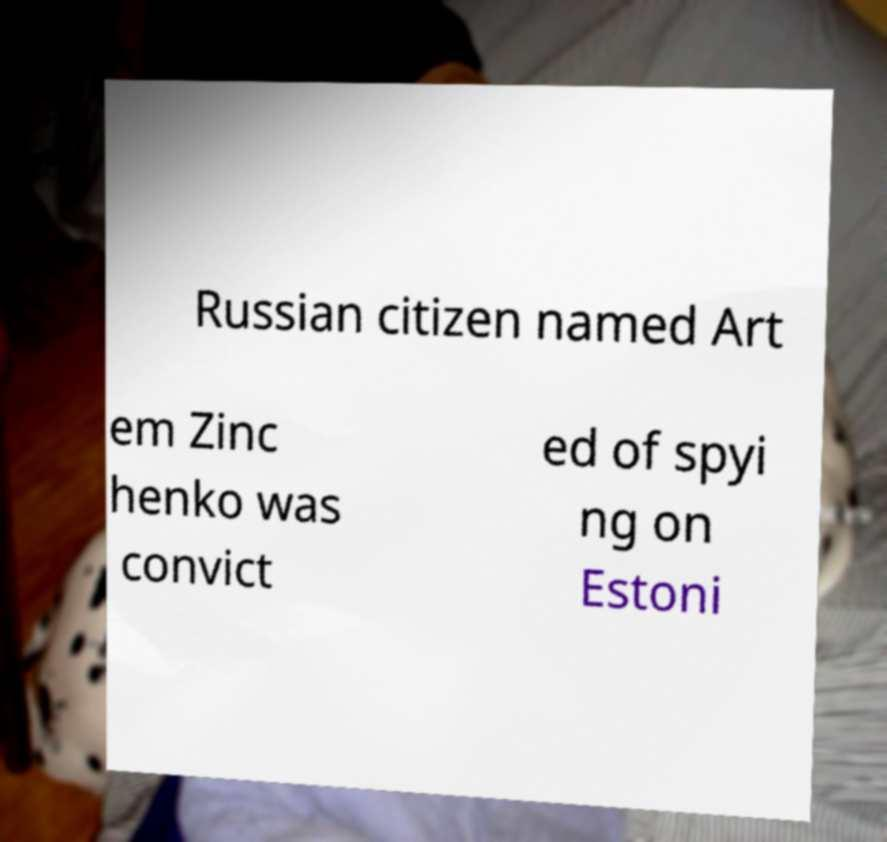Could you extract and type out the text from this image? Russian citizen named Art em Zinc henko was convict ed of spyi ng on Estoni 